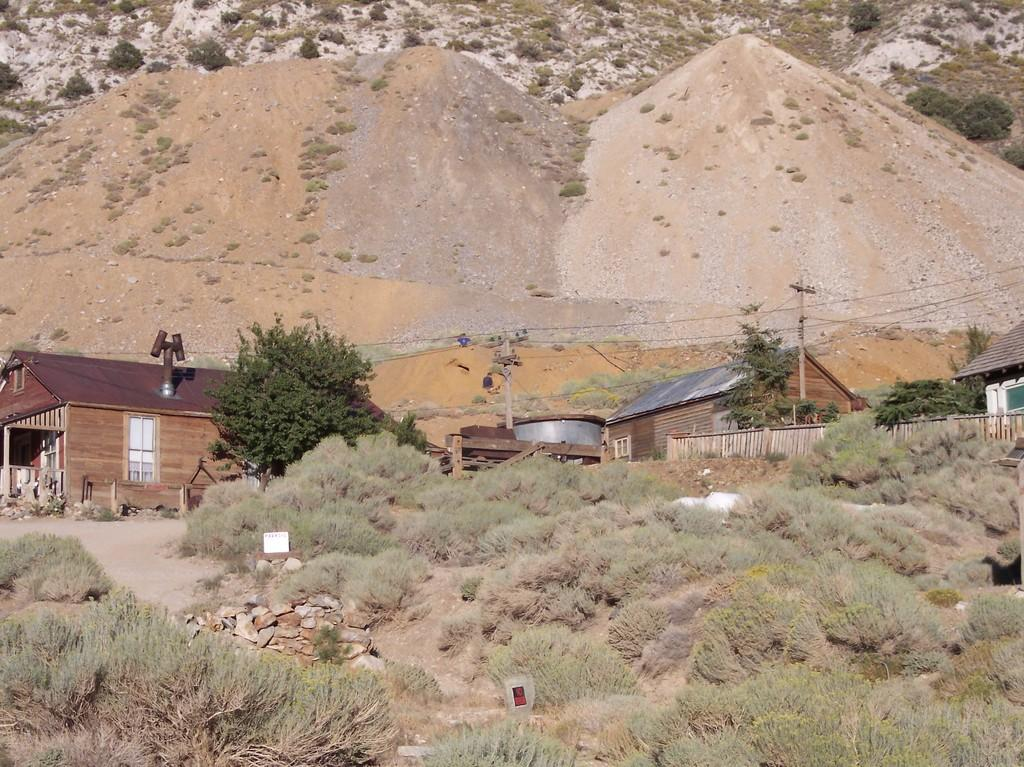What type of natural elements can be seen in the image? Plants, trees, and mountains are visible in the image. What man-made structures are present in the image? There are houses, a fence, and poles in the image. What type of ground cover can be seen in the image? Stones are present in the image. What else can be found in the image besides the mentioned elements? There are objects in the image. What color is the silver tree in the image? There is no silver tree present in the image. 